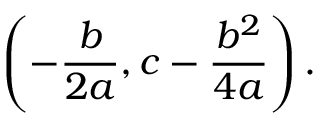Convert formula to latex. <formula><loc_0><loc_0><loc_500><loc_500>\left ( - { \frac { b } { 2 a } } , c - { \frac { b ^ { 2 } } { 4 a } } \right ) .</formula> 